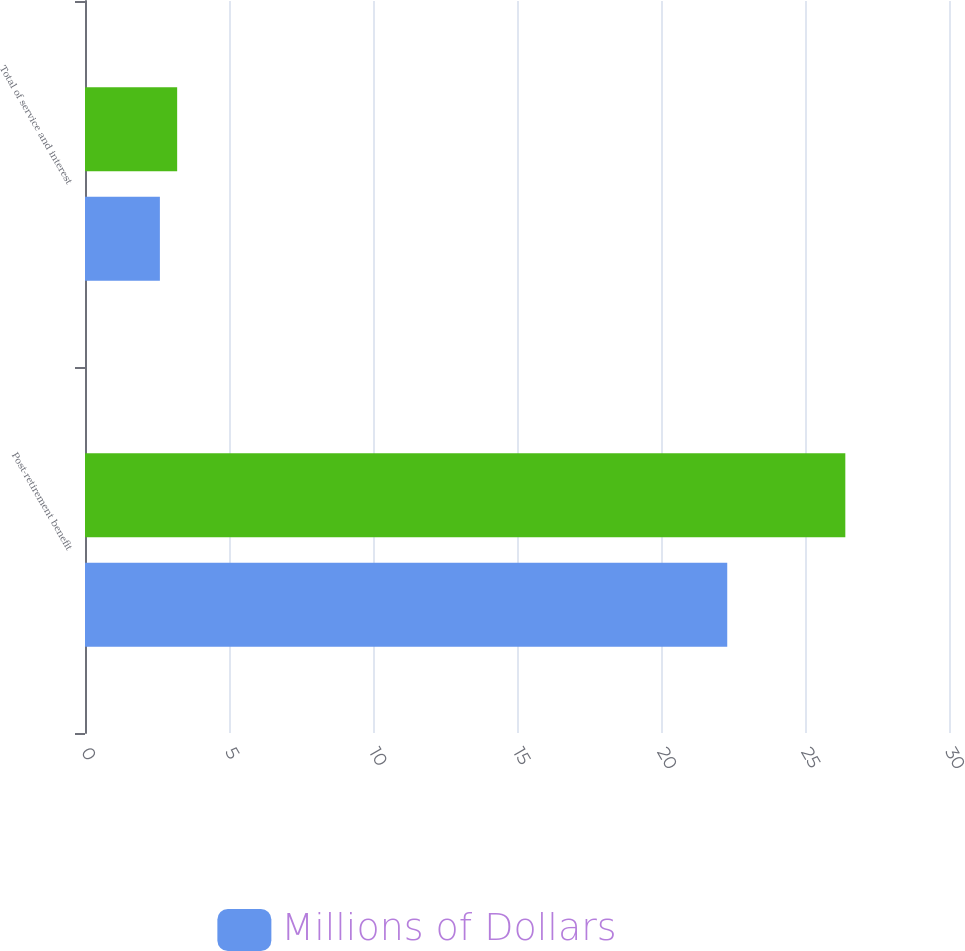Convert chart to OTSL. <chart><loc_0><loc_0><loc_500><loc_500><stacked_bar_chart><ecel><fcel>Post-retirement benefit<fcel>Total of service and interest<nl><fcel>nan<fcel>26.4<fcel>3.2<nl><fcel>Millions of Dollars<fcel>22.3<fcel>2.6<nl></chart> 